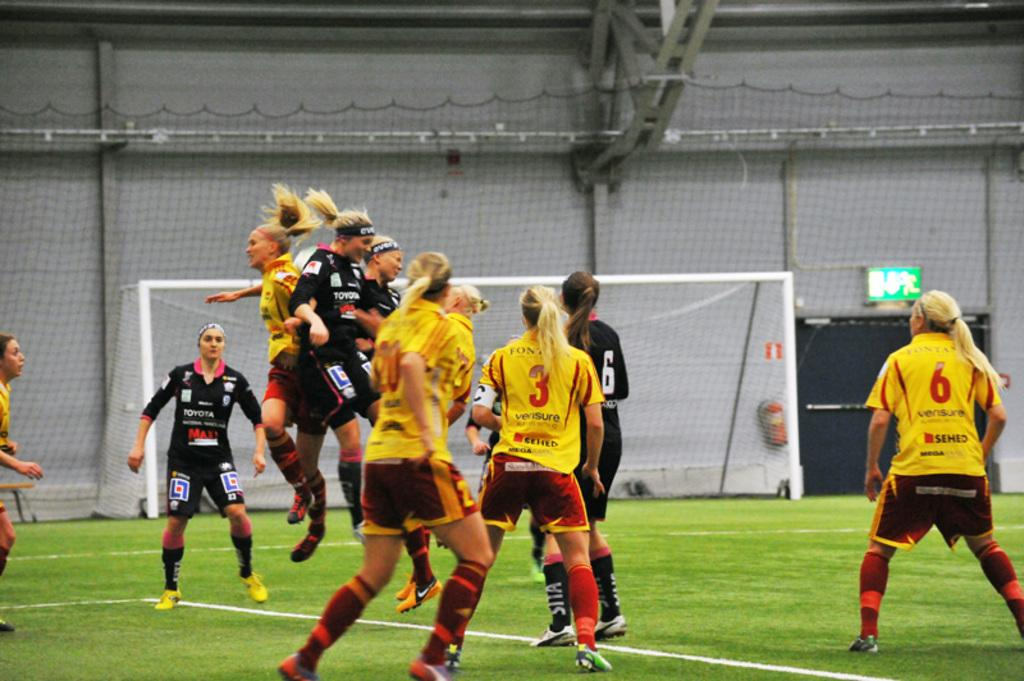What is the surface on which the women are standing in the image? The women are standing on a greenery ground in the image. How many women are in the air in the image? There are three women in the air in the image. What can be seen in the background of the image? There is a net and a fence in the background of the image. What type of zinc is being used to make popcorn in the image? There is no zinc or popcorn present in the image. What arithmetic problem are the women solving in the air? There is no indication of any arithmetic problem being solved in the image. 